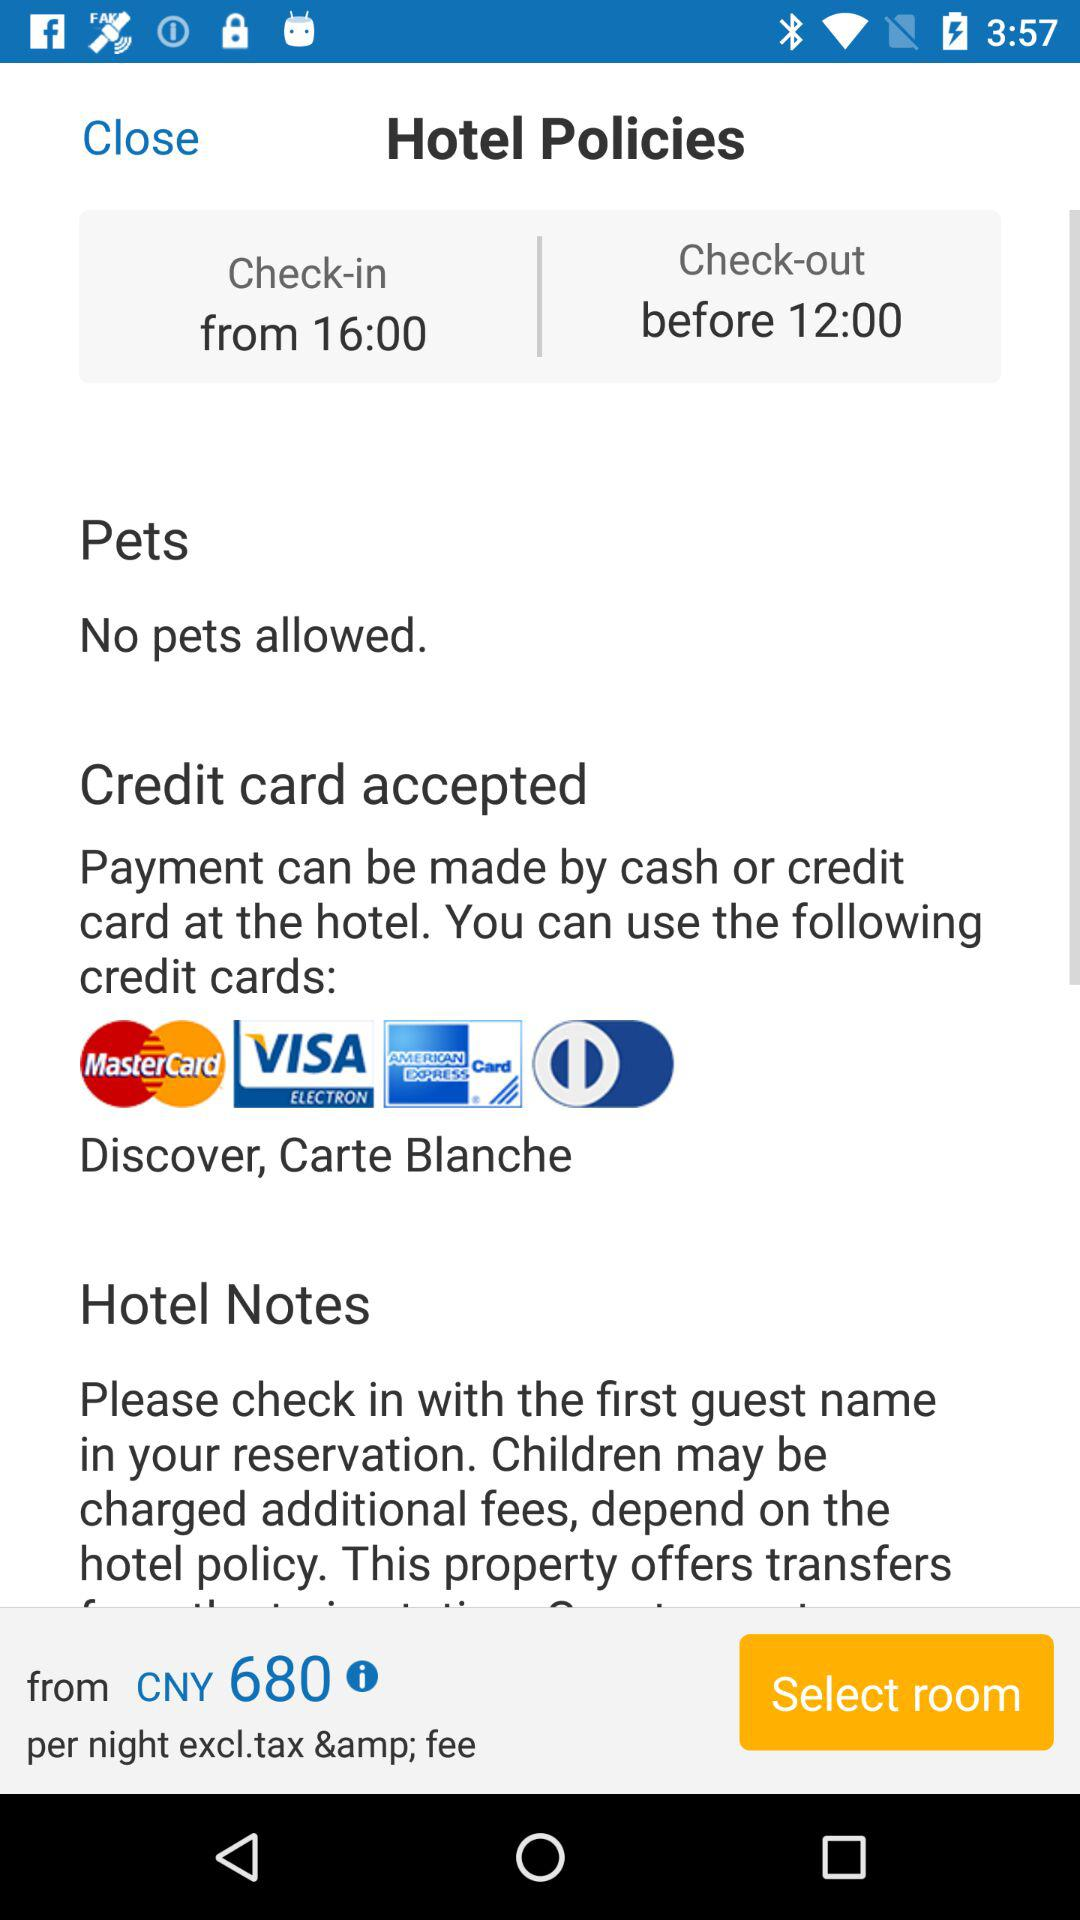What is the check-in time? The check-in time is 16:00. 